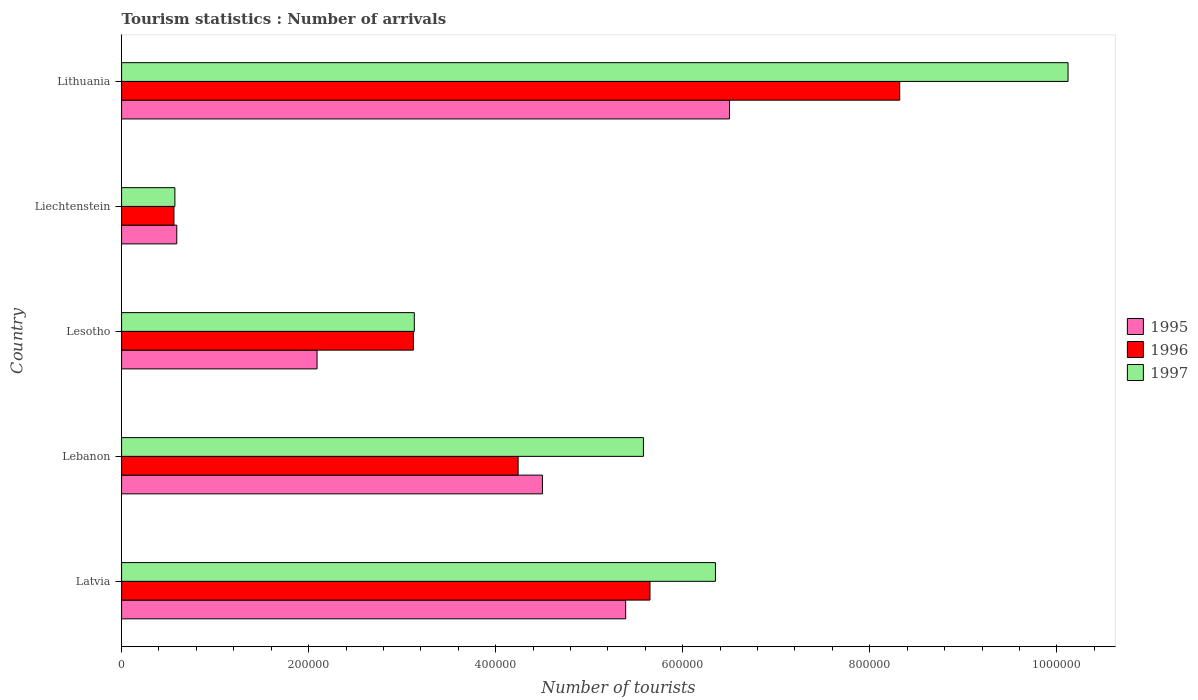How many different coloured bars are there?
Offer a very short reply. 3. Are the number of bars on each tick of the Y-axis equal?
Give a very brief answer. Yes. How many bars are there on the 2nd tick from the bottom?
Your response must be concise. 3. What is the label of the 1st group of bars from the top?
Your answer should be compact. Lithuania. What is the number of tourist arrivals in 1995 in Lithuania?
Your answer should be very brief. 6.50e+05. Across all countries, what is the maximum number of tourist arrivals in 1995?
Your answer should be compact. 6.50e+05. Across all countries, what is the minimum number of tourist arrivals in 1996?
Provide a succinct answer. 5.60e+04. In which country was the number of tourist arrivals in 1997 maximum?
Provide a short and direct response. Lithuania. In which country was the number of tourist arrivals in 1996 minimum?
Your response must be concise. Liechtenstein. What is the total number of tourist arrivals in 1995 in the graph?
Make the answer very short. 1.91e+06. What is the difference between the number of tourist arrivals in 1997 in Liechtenstein and that in Lithuania?
Provide a succinct answer. -9.55e+05. What is the difference between the number of tourist arrivals in 1996 in Liechtenstein and the number of tourist arrivals in 1995 in Latvia?
Your answer should be compact. -4.83e+05. What is the average number of tourist arrivals in 1995 per country?
Provide a short and direct response. 3.81e+05. What is the difference between the number of tourist arrivals in 1996 and number of tourist arrivals in 1997 in Liechtenstein?
Give a very brief answer. -1000. In how many countries, is the number of tourist arrivals in 1996 greater than 920000 ?
Your answer should be very brief. 0. What is the ratio of the number of tourist arrivals in 1996 in Latvia to that in Lithuania?
Provide a succinct answer. 0.68. Is the number of tourist arrivals in 1995 in Latvia less than that in Liechtenstein?
Your answer should be compact. No. What is the difference between the highest and the second highest number of tourist arrivals in 1995?
Offer a very short reply. 1.11e+05. What is the difference between the highest and the lowest number of tourist arrivals in 1996?
Provide a succinct answer. 7.76e+05. In how many countries, is the number of tourist arrivals in 1995 greater than the average number of tourist arrivals in 1995 taken over all countries?
Ensure brevity in your answer.  3. What does the 1st bar from the bottom in Liechtenstein represents?
Provide a succinct answer. 1995. Is it the case that in every country, the sum of the number of tourist arrivals in 1995 and number of tourist arrivals in 1997 is greater than the number of tourist arrivals in 1996?
Keep it short and to the point. Yes. What is the difference between two consecutive major ticks on the X-axis?
Provide a succinct answer. 2.00e+05. How many legend labels are there?
Provide a short and direct response. 3. How are the legend labels stacked?
Make the answer very short. Vertical. What is the title of the graph?
Provide a succinct answer. Tourism statistics : Number of arrivals. Does "1987" appear as one of the legend labels in the graph?
Keep it short and to the point. No. What is the label or title of the X-axis?
Make the answer very short. Number of tourists. What is the label or title of the Y-axis?
Your response must be concise. Country. What is the Number of tourists of 1995 in Latvia?
Keep it short and to the point. 5.39e+05. What is the Number of tourists in 1996 in Latvia?
Your answer should be very brief. 5.65e+05. What is the Number of tourists in 1997 in Latvia?
Provide a succinct answer. 6.35e+05. What is the Number of tourists in 1995 in Lebanon?
Provide a succinct answer. 4.50e+05. What is the Number of tourists in 1996 in Lebanon?
Keep it short and to the point. 4.24e+05. What is the Number of tourists of 1997 in Lebanon?
Your answer should be very brief. 5.58e+05. What is the Number of tourists in 1995 in Lesotho?
Give a very brief answer. 2.09e+05. What is the Number of tourists of 1996 in Lesotho?
Provide a succinct answer. 3.12e+05. What is the Number of tourists of 1997 in Lesotho?
Provide a short and direct response. 3.13e+05. What is the Number of tourists in 1995 in Liechtenstein?
Keep it short and to the point. 5.90e+04. What is the Number of tourists in 1996 in Liechtenstein?
Your answer should be compact. 5.60e+04. What is the Number of tourists in 1997 in Liechtenstein?
Make the answer very short. 5.70e+04. What is the Number of tourists in 1995 in Lithuania?
Your response must be concise. 6.50e+05. What is the Number of tourists in 1996 in Lithuania?
Offer a very short reply. 8.32e+05. What is the Number of tourists in 1997 in Lithuania?
Provide a short and direct response. 1.01e+06. Across all countries, what is the maximum Number of tourists in 1995?
Offer a very short reply. 6.50e+05. Across all countries, what is the maximum Number of tourists of 1996?
Offer a terse response. 8.32e+05. Across all countries, what is the maximum Number of tourists in 1997?
Your response must be concise. 1.01e+06. Across all countries, what is the minimum Number of tourists of 1995?
Your answer should be very brief. 5.90e+04. Across all countries, what is the minimum Number of tourists of 1996?
Ensure brevity in your answer.  5.60e+04. Across all countries, what is the minimum Number of tourists in 1997?
Make the answer very short. 5.70e+04. What is the total Number of tourists of 1995 in the graph?
Provide a succinct answer. 1.91e+06. What is the total Number of tourists of 1996 in the graph?
Offer a very short reply. 2.19e+06. What is the total Number of tourists in 1997 in the graph?
Keep it short and to the point. 2.58e+06. What is the difference between the Number of tourists in 1995 in Latvia and that in Lebanon?
Your answer should be compact. 8.90e+04. What is the difference between the Number of tourists of 1996 in Latvia and that in Lebanon?
Offer a terse response. 1.41e+05. What is the difference between the Number of tourists of 1997 in Latvia and that in Lebanon?
Provide a short and direct response. 7.70e+04. What is the difference between the Number of tourists of 1995 in Latvia and that in Lesotho?
Your response must be concise. 3.30e+05. What is the difference between the Number of tourists of 1996 in Latvia and that in Lesotho?
Give a very brief answer. 2.53e+05. What is the difference between the Number of tourists of 1997 in Latvia and that in Lesotho?
Provide a short and direct response. 3.22e+05. What is the difference between the Number of tourists in 1995 in Latvia and that in Liechtenstein?
Your answer should be very brief. 4.80e+05. What is the difference between the Number of tourists in 1996 in Latvia and that in Liechtenstein?
Provide a succinct answer. 5.09e+05. What is the difference between the Number of tourists in 1997 in Latvia and that in Liechtenstein?
Make the answer very short. 5.78e+05. What is the difference between the Number of tourists of 1995 in Latvia and that in Lithuania?
Offer a very short reply. -1.11e+05. What is the difference between the Number of tourists of 1996 in Latvia and that in Lithuania?
Make the answer very short. -2.67e+05. What is the difference between the Number of tourists of 1997 in Latvia and that in Lithuania?
Your answer should be very brief. -3.77e+05. What is the difference between the Number of tourists of 1995 in Lebanon and that in Lesotho?
Make the answer very short. 2.41e+05. What is the difference between the Number of tourists in 1996 in Lebanon and that in Lesotho?
Make the answer very short. 1.12e+05. What is the difference between the Number of tourists in 1997 in Lebanon and that in Lesotho?
Your answer should be very brief. 2.45e+05. What is the difference between the Number of tourists of 1995 in Lebanon and that in Liechtenstein?
Keep it short and to the point. 3.91e+05. What is the difference between the Number of tourists of 1996 in Lebanon and that in Liechtenstein?
Keep it short and to the point. 3.68e+05. What is the difference between the Number of tourists in 1997 in Lebanon and that in Liechtenstein?
Provide a short and direct response. 5.01e+05. What is the difference between the Number of tourists of 1996 in Lebanon and that in Lithuania?
Your answer should be compact. -4.08e+05. What is the difference between the Number of tourists in 1997 in Lebanon and that in Lithuania?
Provide a succinct answer. -4.54e+05. What is the difference between the Number of tourists of 1995 in Lesotho and that in Liechtenstein?
Make the answer very short. 1.50e+05. What is the difference between the Number of tourists in 1996 in Lesotho and that in Liechtenstein?
Offer a terse response. 2.56e+05. What is the difference between the Number of tourists of 1997 in Lesotho and that in Liechtenstein?
Your response must be concise. 2.56e+05. What is the difference between the Number of tourists in 1995 in Lesotho and that in Lithuania?
Your answer should be compact. -4.41e+05. What is the difference between the Number of tourists of 1996 in Lesotho and that in Lithuania?
Keep it short and to the point. -5.20e+05. What is the difference between the Number of tourists of 1997 in Lesotho and that in Lithuania?
Ensure brevity in your answer.  -6.99e+05. What is the difference between the Number of tourists in 1995 in Liechtenstein and that in Lithuania?
Offer a very short reply. -5.91e+05. What is the difference between the Number of tourists of 1996 in Liechtenstein and that in Lithuania?
Keep it short and to the point. -7.76e+05. What is the difference between the Number of tourists of 1997 in Liechtenstein and that in Lithuania?
Keep it short and to the point. -9.55e+05. What is the difference between the Number of tourists in 1995 in Latvia and the Number of tourists in 1996 in Lebanon?
Offer a very short reply. 1.15e+05. What is the difference between the Number of tourists in 1995 in Latvia and the Number of tourists in 1997 in Lebanon?
Provide a succinct answer. -1.90e+04. What is the difference between the Number of tourists of 1996 in Latvia and the Number of tourists of 1997 in Lebanon?
Your response must be concise. 7000. What is the difference between the Number of tourists in 1995 in Latvia and the Number of tourists in 1996 in Lesotho?
Offer a very short reply. 2.27e+05. What is the difference between the Number of tourists in 1995 in Latvia and the Number of tourists in 1997 in Lesotho?
Ensure brevity in your answer.  2.26e+05. What is the difference between the Number of tourists in 1996 in Latvia and the Number of tourists in 1997 in Lesotho?
Provide a short and direct response. 2.52e+05. What is the difference between the Number of tourists in 1995 in Latvia and the Number of tourists in 1996 in Liechtenstein?
Offer a terse response. 4.83e+05. What is the difference between the Number of tourists in 1995 in Latvia and the Number of tourists in 1997 in Liechtenstein?
Make the answer very short. 4.82e+05. What is the difference between the Number of tourists in 1996 in Latvia and the Number of tourists in 1997 in Liechtenstein?
Keep it short and to the point. 5.08e+05. What is the difference between the Number of tourists in 1995 in Latvia and the Number of tourists in 1996 in Lithuania?
Your answer should be compact. -2.93e+05. What is the difference between the Number of tourists in 1995 in Latvia and the Number of tourists in 1997 in Lithuania?
Your answer should be very brief. -4.73e+05. What is the difference between the Number of tourists of 1996 in Latvia and the Number of tourists of 1997 in Lithuania?
Ensure brevity in your answer.  -4.47e+05. What is the difference between the Number of tourists in 1995 in Lebanon and the Number of tourists in 1996 in Lesotho?
Provide a short and direct response. 1.38e+05. What is the difference between the Number of tourists of 1995 in Lebanon and the Number of tourists of 1997 in Lesotho?
Your answer should be compact. 1.37e+05. What is the difference between the Number of tourists of 1996 in Lebanon and the Number of tourists of 1997 in Lesotho?
Your answer should be compact. 1.11e+05. What is the difference between the Number of tourists of 1995 in Lebanon and the Number of tourists of 1996 in Liechtenstein?
Ensure brevity in your answer.  3.94e+05. What is the difference between the Number of tourists in 1995 in Lebanon and the Number of tourists in 1997 in Liechtenstein?
Provide a short and direct response. 3.93e+05. What is the difference between the Number of tourists in 1996 in Lebanon and the Number of tourists in 1997 in Liechtenstein?
Make the answer very short. 3.67e+05. What is the difference between the Number of tourists of 1995 in Lebanon and the Number of tourists of 1996 in Lithuania?
Your response must be concise. -3.82e+05. What is the difference between the Number of tourists of 1995 in Lebanon and the Number of tourists of 1997 in Lithuania?
Offer a very short reply. -5.62e+05. What is the difference between the Number of tourists in 1996 in Lebanon and the Number of tourists in 1997 in Lithuania?
Your answer should be compact. -5.88e+05. What is the difference between the Number of tourists in 1995 in Lesotho and the Number of tourists in 1996 in Liechtenstein?
Your answer should be very brief. 1.53e+05. What is the difference between the Number of tourists in 1995 in Lesotho and the Number of tourists in 1997 in Liechtenstein?
Offer a very short reply. 1.52e+05. What is the difference between the Number of tourists in 1996 in Lesotho and the Number of tourists in 1997 in Liechtenstein?
Make the answer very short. 2.55e+05. What is the difference between the Number of tourists of 1995 in Lesotho and the Number of tourists of 1996 in Lithuania?
Your response must be concise. -6.23e+05. What is the difference between the Number of tourists in 1995 in Lesotho and the Number of tourists in 1997 in Lithuania?
Give a very brief answer. -8.03e+05. What is the difference between the Number of tourists in 1996 in Lesotho and the Number of tourists in 1997 in Lithuania?
Your answer should be compact. -7.00e+05. What is the difference between the Number of tourists in 1995 in Liechtenstein and the Number of tourists in 1996 in Lithuania?
Offer a very short reply. -7.73e+05. What is the difference between the Number of tourists in 1995 in Liechtenstein and the Number of tourists in 1997 in Lithuania?
Make the answer very short. -9.53e+05. What is the difference between the Number of tourists of 1996 in Liechtenstein and the Number of tourists of 1997 in Lithuania?
Give a very brief answer. -9.56e+05. What is the average Number of tourists in 1995 per country?
Ensure brevity in your answer.  3.81e+05. What is the average Number of tourists in 1996 per country?
Your answer should be compact. 4.38e+05. What is the average Number of tourists in 1997 per country?
Provide a short and direct response. 5.15e+05. What is the difference between the Number of tourists in 1995 and Number of tourists in 1996 in Latvia?
Provide a short and direct response. -2.60e+04. What is the difference between the Number of tourists of 1995 and Number of tourists of 1997 in Latvia?
Your answer should be compact. -9.60e+04. What is the difference between the Number of tourists of 1995 and Number of tourists of 1996 in Lebanon?
Your response must be concise. 2.60e+04. What is the difference between the Number of tourists in 1995 and Number of tourists in 1997 in Lebanon?
Keep it short and to the point. -1.08e+05. What is the difference between the Number of tourists in 1996 and Number of tourists in 1997 in Lebanon?
Provide a short and direct response. -1.34e+05. What is the difference between the Number of tourists in 1995 and Number of tourists in 1996 in Lesotho?
Make the answer very short. -1.03e+05. What is the difference between the Number of tourists in 1995 and Number of tourists in 1997 in Lesotho?
Your answer should be compact. -1.04e+05. What is the difference between the Number of tourists of 1996 and Number of tourists of 1997 in Lesotho?
Your answer should be compact. -1000. What is the difference between the Number of tourists of 1995 and Number of tourists of 1996 in Liechtenstein?
Offer a terse response. 3000. What is the difference between the Number of tourists in 1995 and Number of tourists in 1997 in Liechtenstein?
Offer a terse response. 2000. What is the difference between the Number of tourists in 1996 and Number of tourists in 1997 in Liechtenstein?
Offer a very short reply. -1000. What is the difference between the Number of tourists of 1995 and Number of tourists of 1996 in Lithuania?
Provide a short and direct response. -1.82e+05. What is the difference between the Number of tourists of 1995 and Number of tourists of 1997 in Lithuania?
Keep it short and to the point. -3.62e+05. What is the difference between the Number of tourists in 1996 and Number of tourists in 1997 in Lithuania?
Provide a succinct answer. -1.80e+05. What is the ratio of the Number of tourists of 1995 in Latvia to that in Lebanon?
Give a very brief answer. 1.2. What is the ratio of the Number of tourists of 1996 in Latvia to that in Lebanon?
Offer a very short reply. 1.33. What is the ratio of the Number of tourists of 1997 in Latvia to that in Lebanon?
Your response must be concise. 1.14. What is the ratio of the Number of tourists in 1995 in Latvia to that in Lesotho?
Offer a very short reply. 2.58. What is the ratio of the Number of tourists in 1996 in Latvia to that in Lesotho?
Provide a succinct answer. 1.81. What is the ratio of the Number of tourists of 1997 in Latvia to that in Lesotho?
Your response must be concise. 2.03. What is the ratio of the Number of tourists of 1995 in Latvia to that in Liechtenstein?
Make the answer very short. 9.14. What is the ratio of the Number of tourists of 1996 in Latvia to that in Liechtenstein?
Your answer should be compact. 10.09. What is the ratio of the Number of tourists in 1997 in Latvia to that in Liechtenstein?
Keep it short and to the point. 11.14. What is the ratio of the Number of tourists of 1995 in Latvia to that in Lithuania?
Your answer should be compact. 0.83. What is the ratio of the Number of tourists in 1996 in Latvia to that in Lithuania?
Your answer should be very brief. 0.68. What is the ratio of the Number of tourists in 1997 in Latvia to that in Lithuania?
Your response must be concise. 0.63. What is the ratio of the Number of tourists in 1995 in Lebanon to that in Lesotho?
Provide a short and direct response. 2.15. What is the ratio of the Number of tourists of 1996 in Lebanon to that in Lesotho?
Offer a terse response. 1.36. What is the ratio of the Number of tourists of 1997 in Lebanon to that in Lesotho?
Provide a succinct answer. 1.78. What is the ratio of the Number of tourists in 1995 in Lebanon to that in Liechtenstein?
Provide a short and direct response. 7.63. What is the ratio of the Number of tourists of 1996 in Lebanon to that in Liechtenstein?
Provide a short and direct response. 7.57. What is the ratio of the Number of tourists in 1997 in Lebanon to that in Liechtenstein?
Provide a succinct answer. 9.79. What is the ratio of the Number of tourists of 1995 in Lebanon to that in Lithuania?
Keep it short and to the point. 0.69. What is the ratio of the Number of tourists in 1996 in Lebanon to that in Lithuania?
Your response must be concise. 0.51. What is the ratio of the Number of tourists of 1997 in Lebanon to that in Lithuania?
Your answer should be compact. 0.55. What is the ratio of the Number of tourists in 1995 in Lesotho to that in Liechtenstein?
Offer a very short reply. 3.54. What is the ratio of the Number of tourists in 1996 in Lesotho to that in Liechtenstein?
Provide a short and direct response. 5.57. What is the ratio of the Number of tourists of 1997 in Lesotho to that in Liechtenstein?
Ensure brevity in your answer.  5.49. What is the ratio of the Number of tourists of 1995 in Lesotho to that in Lithuania?
Make the answer very short. 0.32. What is the ratio of the Number of tourists of 1997 in Lesotho to that in Lithuania?
Your response must be concise. 0.31. What is the ratio of the Number of tourists in 1995 in Liechtenstein to that in Lithuania?
Your answer should be compact. 0.09. What is the ratio of the Number of tourists of 1996 in Liechtenstein to that in Lithuania?
Offer a terse response. 0.07. What is the ratio of the Number of tourists of 1997 in Liechtenstein to that in Lithuania?
Your response must be concise. 0.06. What is the difference between the highest and the second highest Number of tourists in 1995?
Your response must be concise. 1.11e+05. What is the difference between the highest and the second highest Number of tourists of 1996?
Your answer should be compact. 2.67e+05. What is the difference between the highest and the second highest Number of tourists of 1997?
Your response must be concise. 3.77e+05. What is the difference between the highest and the lowest Number of tourists in 1995?
Provide a succinct answer. 5.91e+05. What is the difference between the highest and the lowest Number of tourists in 1996?
Provide a succinct answer. 7.76e+05. What is the difference between the highest and the lowest Number of tourists in 1997?
Your answer should be compact. 9.55e+05. 